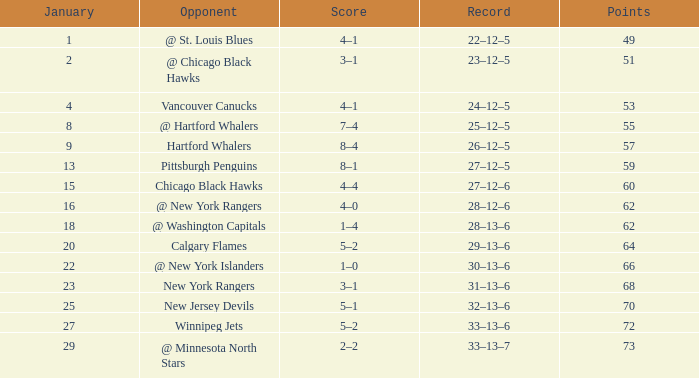Which points own a score of 4-1, and a game under 39? None. 